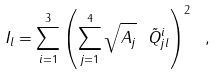<formula> <loc_0><loc_0><loc_500><loc_500>I _ { l } = \sum _ { i = 1 } ^ { 3 } \left ( \sum _ { j = 1 } ^ { 4 } \sqrt { A _ { j } } \ \tilde { Q } _ { j l } ^ { i } \right ) ^ { 2 } \ ,</formula> 